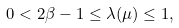Convert formula to latex. <formula><loc_0><loc_0><loc_500><loc_500>0 < 2 \beta - 1 \leq \lambda ( \mu ) \leq 1 ,</formula> 